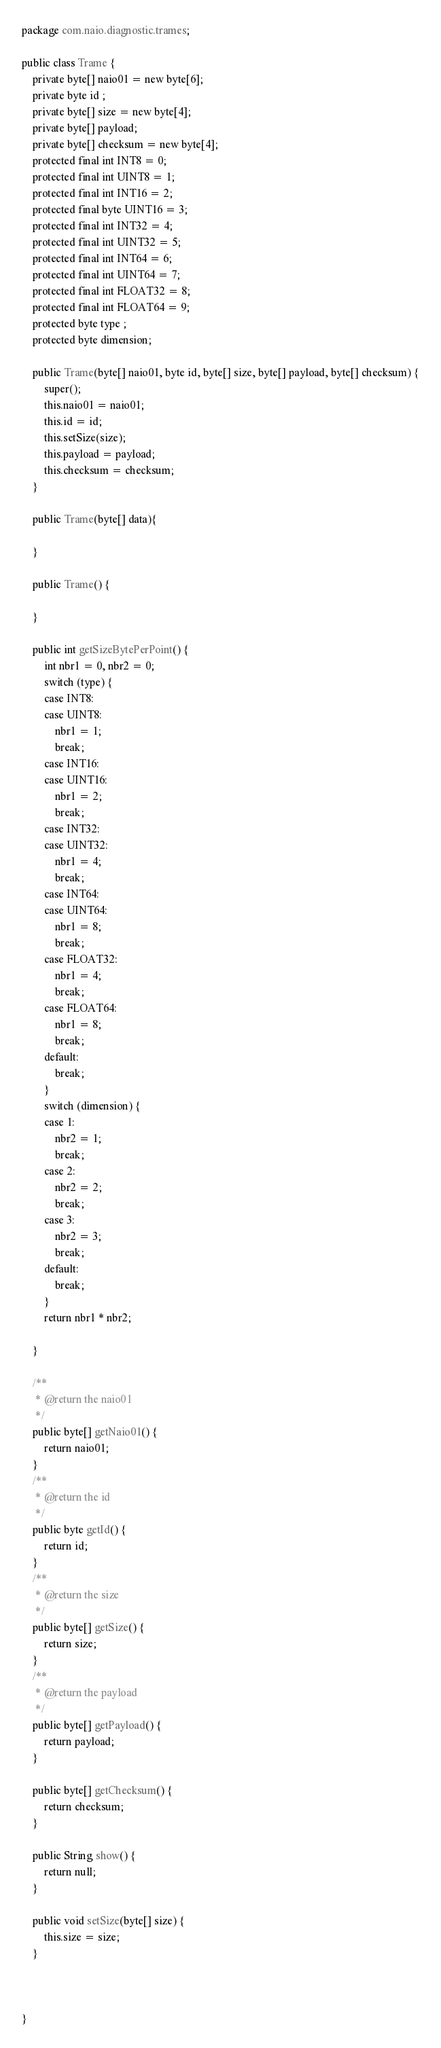<code> <loc_0><loc_0><loc_500><loc_500><_Java_>package com.naio.diagnostic.trames;

public class Trame {
	private byte[] naio01 = new byte[6];
	private byte id ;
	private byte[] size = new byte[4];
	private byte[] payload;
	private byte[] checksum = new byte[4];
	protected final int INT8 = 0;
	protected final int UINT8 = 1;
	protected final int INT16 = 2;
	protected final byte UINT16 = 3;
	protected final int INT32 = 4;
	protected final int UINT32 = 5;
	protected final int INT64 = 6;
	protected final int UINT64 = 7;
	protected final int FLOAT32 = 8;
	protected final int FLOAT64 = 9;
	protected byte type ;
	protected byte dimension;
	
	public Trame(byte[] naio01, byte id, byte[] size, byte[] payload, byte[] checksum) {
		super();
		this.naio01 = naio01;
		this.id = id;
		this.setSize(size);
		this.payload = payload;
		this.checksum = checksum;
	}
	
	public Trame(byte[] data){
		
	}
	
	public Trame() {
		
	}
	
	public int getSizeBytePerPoint() {
		int nbr1 = 0, nbr2 = 0;
		switch (type) {
		case INT8:
		case UINT8:
			nbr1 = 1;
			break;
		case INT16:
		case UINT16:
			nbr1 = 2;
			break;
		case INT32:
		case UINT32:
			nbr1 = 4;
			break;
		case INT64:
		case UINT64:
			nbr1 = 8;
			break;
		case FLOAT32:
			nbr1 = 4;
			break;
		case FLOAT64:
			nbr1 = 8;
			break;
		default:
			break;
		}
		switch (dimension) {
		case 1:
			nbr2 = 1;
			break;
		case 2:
			nbr2 = 2;
			break;
		case 3:
			nbr2 = 3;
			break;
		default:
			break;
		}
		return nbr1 * nbr2;

	}

	/**
	 * @return the naio01
	 */
	public byte[] getNaio01() {
		return naio01;
	}
	/**
	 * @return the id
	 */
	public byte getId() {
		return id;
	}
	/**
	 * @return the size
	 */
	public byte[] getSize() {
		return size;
	}
	/**
	 * @return the payload
	 */
	public byte[] getPayload() {
		return payload;
	}

	public byte[] getChecksum() {
		return checksum;
	}

	public String show() {
		return null;
	}

	public void setSize(byte[] size) {
		this.size = size;
	}

	
	
}
</code> 